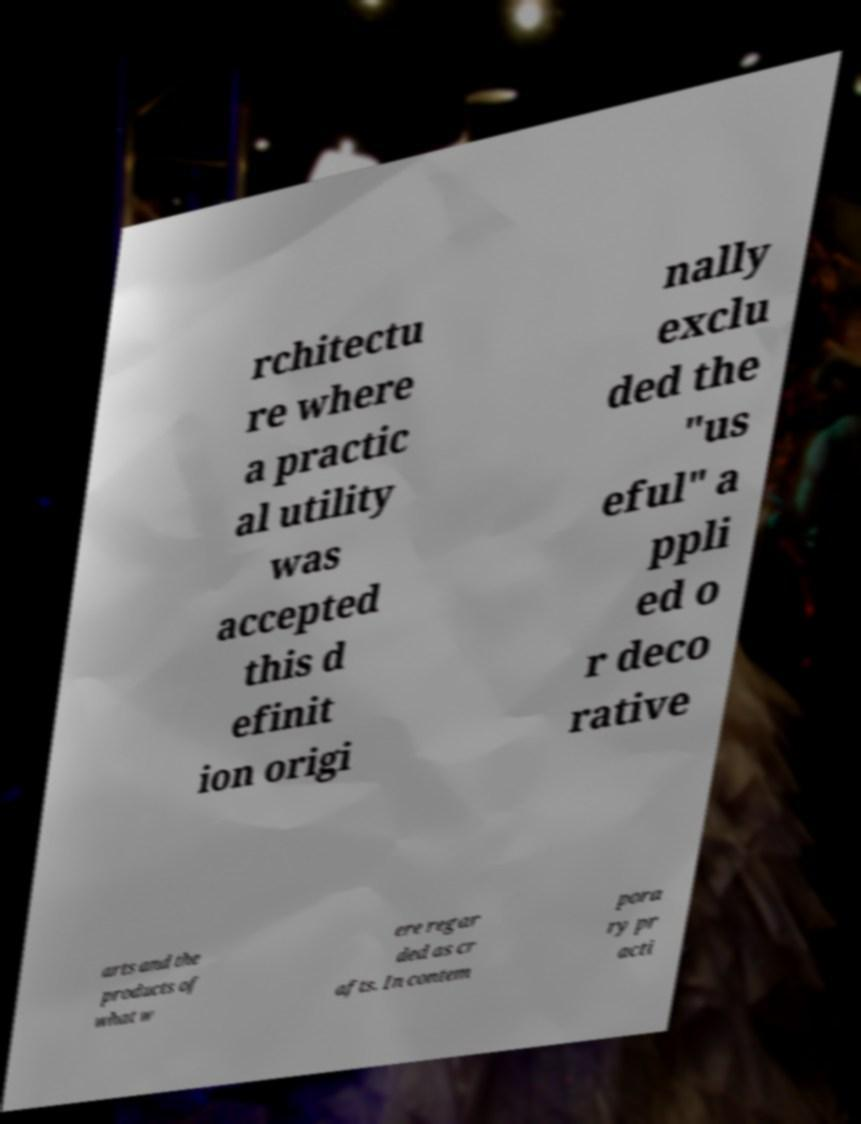There's text embedded in this image that I need extracted. Can you transcribe it verbatim? rchitectu re where a practic al utility was accepted this d efinit ion origi nally exclu ded the "us eful" a ppli ed o r deco rative arts and the products of what w ere regar ded as cr afts. In contem pora ry pr acti 